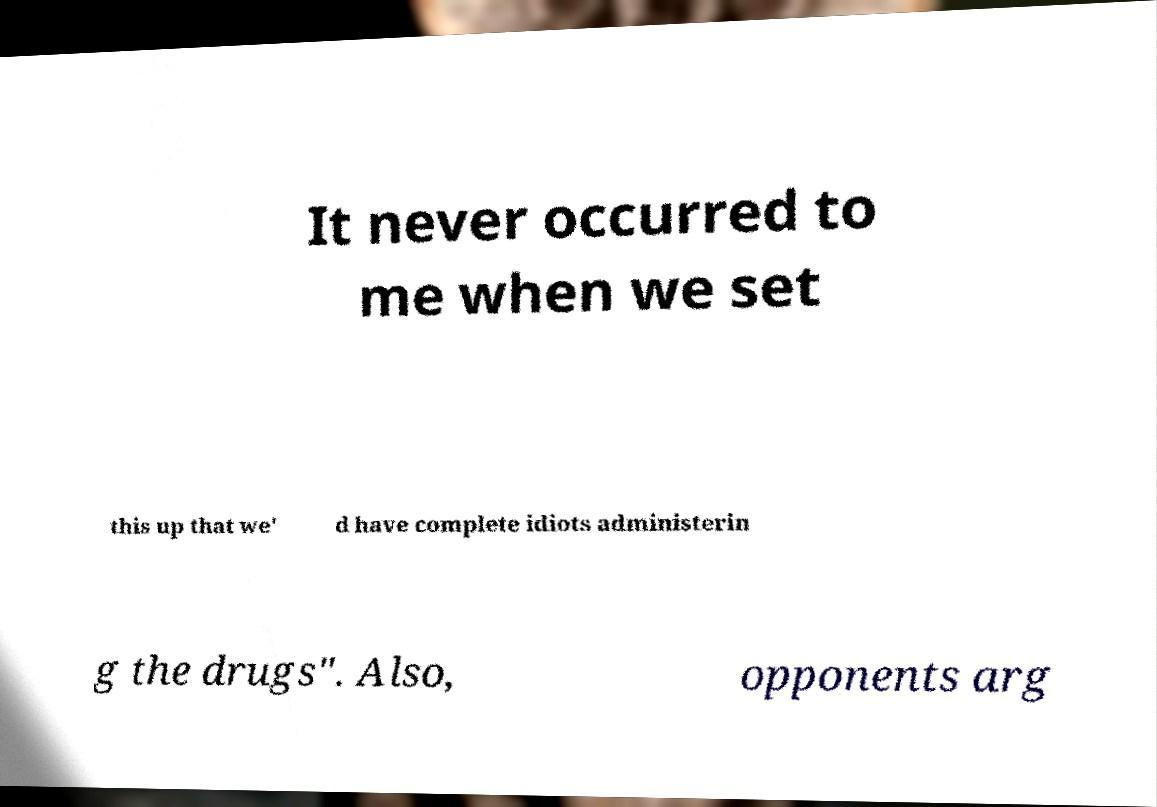There's text embedded in this image that I need extracted. Can you transcribe it verbatim? It never occurred to me when we set this up that we' d have complete idiots administerin g the drugs". Also, opponents arg 